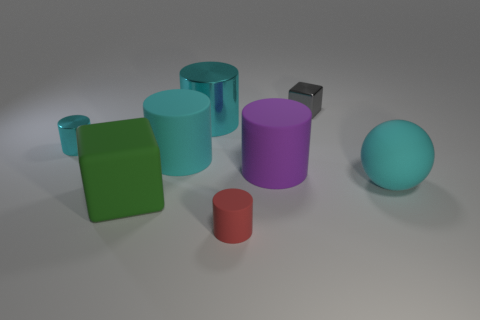Subtract all cyan cylinders. How many were subtracted if there are1cyan cylinders left? 2 Subtract all cyan metallic cylinders. How many cylinders are left? 3 Add 1 large blue metal cylinders. How many objects exist? 9 Subtract all red cylinders. How many cylinders are left? 4 Subtract all green balls. How many cyan cylinders are left? 3 Subtract all spheres. How many objects are left? 7 Subtract 3 cylinders. How many cylinders are left? 2 Subtract all brown spheres. Subtract all yellow blocks. How many spheres are left? 1 Subtract all small blue matte blocks. Subtract all big green blocks. How many objects are left? 7 Add 8 large purple rubber things. How many large purple rubber things are left? 9 